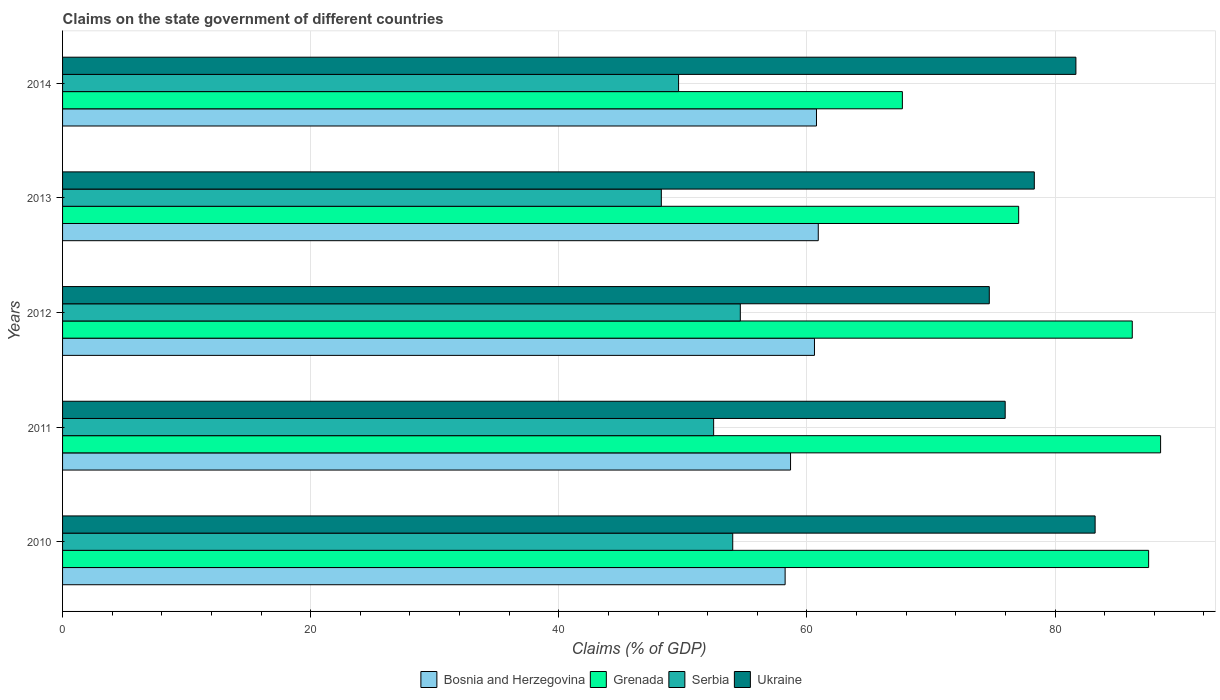How many groups of bars are there?
Keep it short and to the point. 5. Are the number of bars per tick equal to the number of legend labels?
Make the answer very short. Yes. How many bars are there on the 4th tick from the bottom?
Keep it short and to the point. 4. What is the label of the 1st group of bars from the top?
Ensure brevity in your answer.  2014. In how many cases, is the number of bars for a given year not equal to the number of legend labels?
Provide a short and direct response. 0. What is the percentage of GDP claimed on the state government in Grenada in 2013?
Offer a very short reply. 77.07. Across all years, what is the maximum percentage of GDP claimed on the state government in Serbia?
Keep it short and to the point. 54.63. Across all years, what is the minimum percentage of GDP claimed on the state government in Bosnia and Herzegovina?
Make the answer very short. 58.24. In which year was the percentage of GDP claimed on the state government in Bosnia and Herzegovina minimum?
Provide a short and direct response. 2010. What is the total percentage of GDP claimed on the state government in Ukraine in the graph?
Your answer should be compact. 393.92. What is the difference between the percentage of GDP claimed on the state government in Bosnia and Herzegovina in 2010 and that in 2012?
Give a very brief answer. -2.37. What is the difference between the percentage of GDP claimed on the state government in Ukraine in 2010 and the percentage of GDP claimed on the state government in Bosnia and Herzegovina in 2014?
Offer a terse response. 22.46. What is the average percentage of GDP claimed on the state government in Ukraine per year?
Your response must be concise. 78.78. In the year 2013, what is the difference between the percentage of GDP claimed on the state government in Bosnia and Herzegovina and percentage of GDP claimed on the state government in Grenada?
Keep it short and to the point. -16.15. What is the ratio of the percentage of GDP claimed on the state government in Ukraine in 2011 to that in 2014?
Provide a short and direct response. 0.93. Is the difference between the percentage of GDP claimed on the state government in Bosnia and Herzegovina in 2013 and 2014 greater than the difference between the percentage of GDP claimed on the state government in Grenada in 2013 and 2014?
Your answer should be very brief. No. What is the difference between the highest and the second highest percentage of GDP claimed on the state government in Serbia?
Your response must be concise. 0.61. What is the difference between the highest and the lowest percentage of GDP claimed on the state government in Bosnia and Herzegovina?
Offer a very short reply. 2.67. Is it the case that in every year, the sum of the percentage of GDP claimed on the state government in Grenada and percentage of GDP claimed on the state government in Serbia is greater than the sum of percentage of GDP claimed on the state government in Ukraine and percentage of GDP claimed on the state government in Bosnia and Herzegovina?
Ensure brevity in your answer.  No. What does the 4th bar from the top in 2013 represents?
Your response must be concise. Bosnia and Herzegovina. What does the 4th bar from the bottom in 2012 represents?
Ensure brevity in your answer.  Ukraine. How many bars are there?
Your response must be concise. 20. Are all the bars in the graph horizontal?
Give a very brief answer. Yes. How many years are there in the graph?
Your response must be concise. 5. What is the difference between two consecutive major ticks on the X-axis?
Offer a terse response. 20. Does the graph contain any zero values?
Your response must be concise. No. Where does the legend appear in the graph?
Your response must be concise. Bottom center. How are the legend labels stacked?
Provide a succinct answer. Horizontal. What is the title of the graph?
Offer a very short reply. Claims on the state government of different countries. What is the label or title of the X-axis?
Offer a very short reply. Claims (% of GDP). What is the label or title of the Y-axis?
Give a very brief answer. Years. What is the Claims (% of GDP) of Bosnia and Herzegovina in 2010?
Make the answer very short. 58.24. What is the Claims (% of GDP) in Grenada in 2010?
Offer a very short reply. 87.54. What is the Claims (% of GDP) in Serbia in 2010?
Your answer should be compact. 54.02. What is the Claims (% of GDP) of Ukraine in 2010?
Your answer should be compact. 83.23. What is the Claims (% of GDP) in Bosnia and Herzegovina in 2011?
Give a very brief answer. 58.68. What is the Claims (% of GDP) in Grenada in 2011?
Give a very brief answer. 88.51. What is the Claims (% of GDP) of Serbia in 2011?
Provide a succinct answer. 52.48. What is the Claims (% of GDP) of Ukraine in 2011?
Ensure brevity in your answer.  75.98. What is the Claims (% of GDP) of Bosnia and Herzegovina in 2012?
Your response must be concise. 60.61. What is the Claims (% of GDP) of Grenada in 2012?
Your answer should be very brief. 86.22. What is the Claims (% of GDP) in Serbia in 2012?
Your answer should be compact. 54.63. What is the Claims (% of GDP) in Ukraine in 2012?
Keep it short and to the point. 74.7. What is the Claims (% of GDP) of Bosnia and Herzegovina in 2013?
Your answer should be very brief. 60.91. What is the Claims (% of GDP) in Grenada in 2013?
Make the answer very short. 77.07. What is the Claims (% of GDP) in Serbia in 2013?
Offer a terse response. 48.26. What is the Claims (% of GDP) in Ukraine in 2013?
Offer a very short reply. 78.33. What is the Claims (% of GDP) in Bosnia and Herzegovina in 2014?
Keep it short and to the point. 60.77. What is the Claims (% of GDP) in Grenada in 2014?
Offer a very short reply. 67.69. What is the Claims (% of GDP) in Serbia in 2014?
Your response must be concise. 49.65. What is the Claims (% of GDP) in Ukraine in 2014?
Offer a terse response. 81.68. Across all years, what is the maximum Claims (% of GDP) in Bosnia and Herzegovina?
Offer a very short reply. 60.91. Across all years, what is the maximum Claims (% of GDP) of Grenada?
Ensure brevity in your answer.  88.51. Across all years, what is the maximum Claims (% of GDP) in Serbia?
Your response must be concise. 54.63. Across all years, what is the maximum Claims (% of GDP) in Ukraine?
Offer a terse response. 83.23. Across all years, what is the minimum Claims (% of GDP) of Bosnia and Herzegovina?
Make the answer very short. 58.24. Across all years, what is the minimum Claims (% of GDP) in Grenada?
Make the answer very short. 67.69. Across all years, what is the minimum Claims (% of GDP) in Serbia?
Your answer should be compact. 48.26. Across all years, what is the minimum Claims (% of GDP) in Ukraine?
Your response must be concise. 74.7. What is the total Claims (% of GDP) in Bosnia and Herzegovina in the graph?
Keep it short and to the point. 299.21. What is the total Claims (% of GDP) of Grenada in the graph?
Your response must be concise. 407.03. What is the total Claims (% of GDP) in Serbia in the graph?
Offer a terse response. 259.05. What is the total Claims (% of GDP) in Ukraine in the graph?
Give a very brief answer. 393.92. What is the difference between the Claims (% of GDP) in Bosnia and Herzegovina in 2010 and that in 2011?
Ensure brevity in your answer.  -0.44. What is the difference between the Claims (% of GDP) in Grenada in 2010 and that in 2011?
Provide a succinct answer. -0.97. What is the difference between the Claims (% of GDP) in Serbia in 2010 and that in 2011?
Your answer should be compact. 1.54. What is the difference between the Claims (% of GDP) in Ukraine in 2010 and that in 2011?
Your response must be concise. 7.25. What is the difference between the Claims (% of GDP) in Bosnia and Herzegovina in 2010 and that in 2012?
Offer a terse response. -2.37. What is the difference between the Claims (% of GDP) in Grenada in 2010 and that in 2012?
Offer a terse response. 1.32. What is the difference between the Claims (% of GDP) in Serbia in 2010 and that in 2012?
Make the answer very short. -0.61. What is the difference between the Claims (% of GDP) of Ukraine in 2010 and that in 2012?
Offer a very short reply. 8.53. What is the difference between the Claims (% of GDP) in Bosnia and Herzegovina in 2010 and that in 2013?
Provide a succinct answer. -2.67. What is the difference between the Claims (% of GDP) in Grenada in 2010 and that in 2013?
Make the answer very short. 10.47. What is the difference between the Claims (% of GDP) in Serbia in 2010 and that in 2013?
Provide a short and direct response. 5.76. What is the difference between the Claims (% of GDP) in Ukraine in 2010 and that in 2013?
Make the answer very short. 4.9. What is the difference between the Claims (% of GDP) in Bosnia and Herzegovina in 2010 and that in 2014?
Ensure brevity in your answer.  -2.53. What is the difference between the Claims (% of GDP) of Grenada in 2010 and that in 2014?
Your response must be concise. 19.85. What is the difference between the Claims (% of GDP) in Serbia in 2010 and that in 2014?
Your answer should be very brief. 4.37. What is the difference between the Claims (% of GDP) in Ukraine in 2010 and that in 2014?
Your answer should be very brief. 1.55. What is the difference between the Claims (% of GDP) in Bosnia and Herzegovina in 2011 and that in 2012?
Ensure brevity in your answer.  -1.93. What is the difference between the Claims (% of GDP) in Grenada in 2011 and that in 2012?
Offer a terse response. 2.28. What is the difference between the Claims (% of GDP) of Serbia in 2011 and that in 2012?
Keep it short and to the point. -2.15. What is the difference between the Claims (% of GDP) in Ukraine in 2011 and that in 2012?
Your answer should be very brief. 1.28. What is the difference between the Claims (% of GDP) in Bosnia and Herzegovina in 2011 and that in 2013?
Provide a short and direct response. -2.23. What is the difference between the Claims (% of GDP) of Grenada in 2011 and that in 2013?
Make the answer very short. 11.44. What is the difference between the Claims (% of GDP) in Serbia in 2011 and that in 2013?
Offer a terse response. 4.22. What is the difference between the Claims (% of GDP) of Ukraine in 2011 and that in 2013?
Keep it short and to the point. -2.35. What is the difference between the Claims (% of GDP) of Bosnia and Herzegovina in 2011 and that in 2014?
Your answer should be compact. -2.09. What is the difference between the Claims (% of GDP) of Grenada in 2011 and that in 2014?
Provide a short and direct response. 20.81. What is the difference between the Claims (% of GDP) in Serbia in 2011 and that in 2014?
Offer a very short reply. 2.83. What is the difference between the Claims (% of GDP) of Ukraine in 2011 and that in 2014?
Provide a short and direct response. -5.7. What is the difference between the Claims (% of GDP) of Bosnia and Herzegovina in 2012 and that in 2013?
Your answer should be very brief. -0.31. What is the difference between the Claims (% of GDP) in Grenada in 2012 and that in 2013?
Provide a succinct answer. 9.16. What is the difference between the Claims (% of GDP) in Serbia in 2012 and that in 2013?
Your answer should be very brief. 6.37. What is the difference between the Claims (% of GDP) in Ukraine in 2012 and that in 2013?
Keep it short and to the point. -3.63. What is the difference between the Claims (% of GDP) of Bosnia and Herzegovina in 2012 and that in 2014?
Your answer should be very brief. -0.16. What is the difference between the Claims (% of GDP) in Grenada in 2012 and that in 2014?
Provide a short and direct response. 18.53. What is the difference between the Claims (% of GDP) of Serbia in 2012 and that in 2014?
Your answer should be compact. 4.98. What is the difference between the Claims (% of GDP) of Ukraine in 2012 and that in 2014?
Provide a short and direct response. -6.98. What is the difference between the Claims (% of GDP) in Bosnia and Herzegovina in 2013 and that in 2014?
Offer a terse response. 0.14. What is the difference between the Claims (% of GDP) in Grenada in 2013 and that in 2014?
Provide a succinct answer. 9.37. What is the difference between the Claims (% of GDP) in Serbia in 2013 and that in 2014?
Your answer should be very brief. -1.39. What is the difference between the Claims (% of GDP) of Ukraine in 2013 and that in 2014?
Your answer should be very brief. -3.35. What is the difference between the Claims (% of GDP) in Bosnia and Herzegovina in 2010 and the Claims (% of GDP) in Grenada in 2011?
Offer a very short reply. -30.26. What is the difference between the Claims (% of GDP) of Bosnia and Herzegovina in 2010 and the Claims (% of GDP) of Serbia in 2011?
Give a very brief answer. 5.76. What is the difference between the Claims (% of GDP) of Bosnia and Herzegovina in 2010 and the Claims (% of GDP) of Ukraine in 2011?
Make the answer very short. -17.74. What is the difference between the Claims (% of GDP) of Grenada in 2010 and the Claims (% of GDP) of Serbia in 2011?
Provide a succinct answer. 35.06. What is the difference between the Claims (% of GDP) in Grenada in 2010 and the Claims (% of GDP) in Ukraine in 2011?
Your answer should be compact. 11.56. What is the difference between the Claims (% of GDP) of Serbia in 2010 and the Claims (% of GDP) of Ukraine in 2011?
Offer a very short reply. -21.96. What is the difference between the Claims (% of GDP) of Bosnia and Herzegovina in 2010 and the Claims (% of GDP) of Grenada in 2012?
Make the answer very short. -27.98. What is the difference between the Claims (% of GDP) of Bosnia and Herzegovina in 2010 and the Claims (% of GDP) of Serbia in 2012?
Provide a short and direct response. 3.61. What is the difference between the Claims (% of GDP) in Bosnia and Herzegovina in 2010 and the Claims (% of GDP) in Ukraine in 2012?
Offer a very short reply. -16.46. What is the difference between the Claims (% of GDP) of Grenada in 2010 and the Claims (% of GDP) of Serbia in 2012?
Provide a short and direct response. 32.91. What is the difference between the Claims (% of GDP) in Grenada in 2010 and the Claims (% of GDP) in Ukraine in 2012?
Keep it short and to the point. 12.84. What is the difference between the Claims (% of GDP) of Serbia in 2010 and the Claims (% of GDP) of Ukraine in 2012?
Make the answer very short. -20.68. What is the difference between the Claims (% of GDP) in Bosnia and Herzegovina in 2010 and the Claims (% of GDP) in Grenada in 2013?
Your response must be concise. -18.82. What is the difference between the Claims (% of GDP) of Bosnia and Herzegovina in 2010 and the Claims (% of GDP) of Serbia in 2013?
Your response must be concise. 9.98. What is the difference between the Claims (% of GDP) of Bosnia and Herzegovina in 2010 and the Claims (% of GDP) of Ukraine in 2013?
Offer a very short reply. -20.09. What is the difference between the Claims (% of GDP) in Grenada in 2010 and the Claims (% of GDP) in Serbia in 2013?
Ensure brevity in your answer.  39.28. What is the difference between the Claims (% of GDP) of Grenada in 2010 and the Claims (% of GDP) of Ukraine in 2013?
Your answer should be very brief. 9.21. What is the difference between the Claims (% of GDP) in Serbia in 2010 and the Claims (% of GDP) in Ukraine in 2013?
Your response must be concise. -24.31. What is the difference between the Claims (% of GDP) in Bosnia and Herzegovina in 2010 and the Claims (% of GDP) in Grenada in 2014?
Offer a terse response. -9.45. What is the difference between the Claims (% of GDP) in Bosnia and Herzegovina in 2010 and the Claims (% of GDP) in Serbia in 2014?
Offer a very short reply. 8.59. What is the difference between the Claims (% of GDP) in Bosnia and Herzegovina in 2010 and the Claims (% of GDP) in Ukraine in 2014?
Give a very brief answer. -23.44. What is the difference between the Claims (% of GDP) of Grenada in 2010 and the Claims (% of GDP) of Serbia in 2014?
Provide a short and direct response. 37.89. What is the difference between the Claims (% of GDP) in Grenada in 2010 and the Claims (% of GDP) in Ukraine in 2014?
Provide a succinct answer. 5.86. What is the difference between the Claims (% of GDP) of Serbia in 2010 and the Claims (% of GDP) of Ukraine in 2014?
Give a very brief answer. -27.66. What is the difference between the Claims (% of GDP) of Bosnia and Herzegovina in 2011 and the Claims (% of GDP) of Grenada in 2012?
Keep it short and to the point. -27.54. What is the difference between the Claims (% of GDP) of Bosnia and Herzegovina in 2011 and the Claims (% of GDP) of Serbia in 2012?
Make the answer very short. 4.05. What is the difference between the Claims (% of GDP) of Bosnia and Herzegovina in 2011 and the Claims (% of GDP) of Ukraine in 2012?
Give a very brief answer. -16.02. What is the difference between the Claims (% of GDP) of Grenada in 2011 and the Claims (% of GDP) of Serbia in 2012?
Make the answer very short. 33.88. What is the difference between the Claims (% of GDP) of Grenada in 2011 and the Claims (% of GDP) of Ukraine in 2012?
Your answer should be very brief. 13.81. What is the difference between the Claims (% of GDP) of Serbia in 2011 and the Claims (% of GDP) of Ukraine in 2012?
Your answer should be very brief. -22.22. What is the difference between the Claims (% of GDP) of Bosnia and Herzegovina in 2011 and the Claims (% of GDP) of Grenada in 2013?
Offer a very short reply. -18.39. What is the difference between the Claims (% of GDP) in Bosnia and Herzegovina in 2011 and the Claims (% of GDP) in Serbia in 2013?
Offer a terse response. 10.41. What is the difference between the Claims (% of GDP) in Bosnia and Herzegovina in 2011 and the Claims (% of GDP) in Ukraine in 2013?
Your answer should be very brief. -19.65. What is the difference between the Claims (% of GDP) in Grenada in 2011 and the Claims (% of GDP) in Serbia in 2013?
Your answer should be very brief. 40.24. What is the difference between the Claims (% of GDP) in Grenada in 2011 and the Claims (% of GDP) in Ukraine in 2013?
Give a very brief answer. 10.18. What is the difference between the Claims (% of GDP) of Serbia in 2011 and the Claims (% of GDP) of Ukraine in 2013?
Offer a terse response. -25.85. What is the difference between the Claims (% of GDP) in Bosnia and Herzegovina in 2011 and the Claims (% of GDP) in Grenada in 2014?
Provide a succinct answer. -9.01. What is the difference between the Claims (% of GDP) in Bosnia and Herzegovina in 2011 and the Claims (% of GDP) in Serbia in 2014?
Provide a short and direct response. 9.03. What is the difference between the Claims (% of GDP) of Bosnia and Herzegovina in 2011 and the Claims (% of GDP) of Ukraine in 2014?
Offer a very short reply. -23. What is the difference between the Claims (% of GDP) in Grenada in 2011 and the Claims (% of GDP) in Serbia in 2014?
Offer a very short reply. 38.85. What is the difference between the Claims (% of GDP) in Grenada in 2011 and the Claims (% of GDP) in Ukraine in 2014?
Offer a very short reply. 6.83. What is the difference between the Claims (% of GDP) in Serbia in 2011 and the Claims (% of GDP) in Ukraine in 2014?
Your answer should be very brief. -29.2. What is the difference between the Claims (% of GDP) of Bosnia and Herzegovina in 2012 and the Claims (% of GDP) of Grenada in 2013?
Give a very brief answer. -16.46. What is the difference between the Claims (% of GDP) in Bosnia and Herzegovina in 2012 and the Claims (% of GDP) in Serbia in 2013?
Make the answer very short. 12.34. What is the difference between the Claims (% of GDP) in Bosnia and Herzegovina in 2012 and the Claims (% of GDP) in Ukraine in 2013?
Your response must be concise. -17.72. What is the difference between the Claims (% of GDP) in Grenada in 2012 and the Claims (% of GDP) in Serbia in 2013?
Offer a terse response. 37.96. What is the difference between the Claims (% of GDP) of Grenada in 2012 and the Claims (% of GDP) of Ukraine in 2013?
Your answer should be very brief. 7.9. What is the difference between the Claims (% of GDP) in Serbia in 2012 and the Claims (% of GDP) in Ukraine in 2013?
Your response must be concise. -23.7. What is the difference between the Claims (% of GDP) of Bosnia and Herzegovina in 2012 and the Claims (% of GDP) of Grenada in 2014?
Keep it short and to the point. -7.09. What is the difference between the Claims (% of GDP) of Bosnia and Herzegovina in 2012 and the Claims (% of GDP) of Serbia in 2014?
Ensure brevity in your answer.  10.95. What is the difference between the Claims (% of GDP) in Bosnia and Herzegovina in 2012 and the Claims (% of GDP) in Ukraine in 2014?
Your answer should be very brief. -21.07. What is the difference between the Claims (% of GDP) in Grenada in 2012 and the Claims (% of GDP) in Serbia in 2014?
Your answer should be very brief. 36.57. What is the difference between the Claims (% of GDP) in Grenada in 2012 and the Claims (% of GDP) in Ukraine in 2014?
Make the answer very short. 4.54. What is the difference between the Claims (% of GDP) of Serbia in 2012 and the Claims (% of GDP) of Ukraine in 2014?
Keep it short and to the point. -27.05. What is the difference between the Claims (% of GDP) in Bosnia and Herzegovina in 2013 and the Claims (% of GDP) in Grenada in 2014?
Your answer should be compact. -6.78. What is the difference between the Claims (% of GDP) of Bosnia and Herzegovina in 2013 and the Claims (% of GDP) of Serbia in 2014?
Your answer should be very brief. 11.26. What is the difference between the Claims (% of GDP) in Bosnia and Herzegovina in 2013 and the Claims (% of GDP) in Ukraine in 2014?
Offer a terse response. -20.77. What is the difference between the Claims (% of GDP) of Grenada in 2013 and the Claims (% of GDP) of Serbia in 2014?
Give a very brief answer. 27.41. What is the difference between the Claims (% of GDP) of Grenada in 2013 and the Claims (% of GDP) of Ukraine in 2014?
Keep it short and to the point. -4.61. What is the difference between the Claims (% of GDP) of Serbia in 2013 and the Claims (% of GDP) of Ukraine in 2014?
Make the answer very short. -33.42. What is the average Claims (% of GDP) in Bosnia and Herzegovina per year?
Offer a terse response. 59.84. What is the average Claims (% of GDP) in Grenada per year?
Keep it short and to the point. 81.41. What is the average Claims (% of GDP) of Serbia per year?
Keep it short and to the point. 51.81. What is the average Claims (% of GDP) in Ukraine per year?
Offer a very short reply. 78.78. In the year 2010, what is the difference between the Claims (% of GDP) in Bosnia and Herzegovina and Claims (% of GDP) in Grenada?
Your answer should be very brief. -29.3. In the year 2010, what is the difference between the Claims (% of GDP) of Bosnia and Herzegovina and Claims (% of GDP) of Serbia?
Your answer should be very brief. 4.22. In the year 2010, what is the difference between the Claims (% of GDP) of Bosnia and Herzegovina and Claims (% of GDP) of Ukraine?
Keep it short and to the point. -24.99. In the year 2010, what is the difference between the Claims (% of GDP) of Grenada and Claims (% of GDP) of Serbia?
Give a very brief answer. 33.52. In the year 2010, what is the difference between the Claims (% of GDP) of Grenada and Claims (% of GDP) of Ukraine?
Provide a succinct answer. 4.31. In the year 2010, what is the difference between the Claims (% of GDP) in Serbia and Claims (% of GDP) in Ukraine?
Your answer should be compact. -29.21. In the year 2011, what is the difference between the Claims (% of GDP) in Bosnia and Herzegovina and Claims (% of GDP) in Grenada?
Make the answer very short. -29.83. In the year 2011, what is the difference between the Claims (% of GDP) of Bosnia and Herzegovina and Claims (% of GDP) of Serbia?
Provide a succinct answer. 6.2. In the year 2011, what is the difference between the Claims (% of GDP) of Bosnia and Herzegovina and Claims (% of GDP) of Ukraine?
Your answer should be compact. -17.3. In the year 2011, what is the difference between the Claims (% of GDP) in Grenada and Claims (% of GDP) in Serbia?
Your response must be concise. 36.03. In the year 2011, what is the difference between the Claims (% of GDP) of Grenada and Claims (% of GDP) of Ukraine?
Ensure brevity in your answer.  12.53. In the year 2011, what is the difference between the Claims (% of GDP) of Serbia and Claims (% of GDP) of Ukraine?
Provide a short and direct response. -23.5. In the year 2012, what is the difference between the Claims (% of GDP) of Bosnia and Herzegovina and Claims (% of GDP) of Grenada?
Keep it short and to the point. -25.62. In the year 2012, what is the difference between the Claims (% of GDP) in Bosnia and Herzegovina and Claims (% of GDP) in Serbia?
Keep it short and to the point. 5.98. In the year 2012, what is the difference between the Claims (% of GDP) in Bosnia and Herzegovina and Claims (% of GDP) in Ukraine?
Your response must be concise. -14.09. In the year 2012, what is the difference between the Claims (% of GDP) of Grenada and Claims (% of GDP) of Serbia?
Offer a very short reply. 31.59. In the year 2012, what is the difference between the Claims (% of GDP) of Grenada and Claims (% of GDP) of Ukraine?
Offer a very short reply. 11.52. In the year 2012, what is the difference between the Claims (% of GDP) in Serbia and Claims (% of GDP) in Ukraine?
Provide a succinct answer. -20.07. In the year 2013, what is the difference between the Claims (% of GDP) in Bosnia and Herzegovina and Claims (% of GDP) in Grenada?
Offer a terse response. -16.15. In the year 2013, what is the difference between the Claims (% of GDP) of Bosnia and Herzegovina and Claims (% of GDP) of Serbia?
Keep it short and to the point. 12.65. In the year 2013, what is the difference between the Claims (% of GDP) of Bosnia and Herzegovina and Claims (% of GDP) of Ukraine?
Your answer should be very brief. -17.41. In the year 2013, what is the difference between the Claims (% of GDP) in Grenada and Claims (% of GDP) in Serbia?
Ensure brevity in your answer.  28.8. In the year 2013, what is the difference between the Claims (% of GDP) of Grenada and Claims (% of GDP) of Ukraine?
Make the answer very short. -1.26. In the year 2013, what is the difference between the Claims (% of GDP) in Serbia and Claims (% of GDP) in Ukraine?
Offer a terse response. -30.06. In the year 2014, what is the difference between the Claims (% of GDP) in Bosnia and Herzegovina and Claims (% of GDP) in Grenada?
Ensure brevity in your answer.  -6.92. In the year 2014, what is the difference between the Claims (% of GDP) of Bosnia and Herzegovina and Claims (% of GDP) of Serbia?
Ensure brevity in your answer.  11.12. In the year 2014, what is the difference between the Claims (% of GDP) in Bosnia and Herzegovina and Claims (% of GDP) in Ukraine?
Provide a short and direct response. -20.91. In the year 2014, what is the difference between the Claims (% of GDP) in Grenada and Claims (% of GDP) in Serbia?
Your answer should be compact. 18.04. In the year 2014, what is the difference between the Claims (% of GDP) in Grenada and Claims (% of GDP) in Ukraine?
Your answer should be compact. -13.99. In the year 2014, what is the difference between the Claims (% of GDP) of Serbia and Claims (% of GDP) of Ukraine?
Make the answer very short. -32.03. What is the ratio of the Claims (% of GDP) of Grenada in 2010 to that in 2011?
Offer a very short reply. 0.99. What is the ratio of the Claims (% of GDP) in Serbia in 2010 to that in 2011?
Make the answer very short. 1.03. What is the ratio of the Claims (% of GDP) of Ukraine in 2010 to that in 2011?
Offer a very short reply. 1.1. What is the ratio of the Claims (% of GDP) of Bosnia and Herzegovina in 2010 to that in 2012?
Your answer should be very brief. 0.96. What is the ratio of the Claims (% of GDP) in Grenada in 2010 to that in 2012?
Provide a short and direct response. 1.02. What is the ratio of the Claims (% of GDP) of Ukraine in 2010 to that in 2012?
Give a very brief answer. 1.11. What is the ratio of the Claims (% of GDP) in Bosnia and Herzegovina in 2010 to that in 2013?
Offer a very short reply. 0.96. What is the ratio of the Claims (% of GDP) of Grenada in 2010 to that in 2013?
Keep it short and to the point. 1.14. What is the ratio of the Claims (% of GDP) of Serbia in 2010 to that in 2013?
Your answer should be compact. 1.12. What is the ratio of the Claims (% of GDP) in Ukraine in 2010 to that in 2013?
Make the answer very short. 1.06. What is the ratio of the Claims (% of GDP) of Bosnia and Herzegovina in 2010 to that in 2014?
Make the answer very short. 0.96. What is the ratio of the Claims (% of GDP) in Grenada in 2010 to that in 2014?
Ensure brevity in your answer.  1.29. What is the ratio of the Claims (% of GDP) of Serbia in 2010 to that in 2014?
Your answer should be compact. 1.09. What is the ratio of the Claims (% of GDP) in Ukraine in 2010 to that in 2014?
Keep it short and to the point. 1.02. What is the ratio of the Claims (% of GDP) of Bosnia and Herzegovina in 2011 to that in 2012?
Your response must be concise. 0.97. What is the ratio of the Claims (% of GDP) in Grenada in 2011 to that in 2012?
Your answer should be compact. 1.03. What is the ratio of the Claims (% of GDP) of Serbia in 2011 to that in 2012?
Keep it short and to the point. 0.96. What is the ratio of the Claims (% of GDP) of Ukraine in 2011 to that in 2012?
Your answer should be very brief. 1.02. What is the ratio of the Claims (% of GDP) in Bosnia and Herzegovina in 2011 to that in 2013?
Make the answer very short. 0.96. What is the ratio of the Claims (% of GDP) in Grenada in 2011 to that in 2013?
Your answer should be compact. 1.15. What is the ratio of the Claims (% of GDP) in Serbia in 2011 to that in 2013?
Provide a succinct answer. 1.09. What is the ratio of the Claims (% of GDP) in Ukraine in 2011 to that in 2013?
Ensure brevity in your answer.  0.97. What is the ratio of the Claims (% of GDP) in Bosnia and Herzegovina in 2011 to that in 2014?
Ensure brevity in your answer.  0.97. What is the ratio of the Claims (% of GDP) in Grenada in 2011 to that in 2014?
Keep it short and to the point. 1.31. What is the ratio of the Claims (% of GDP) in Serbia in 2011 to that in 2014?
Keep it short and to the point. 1.06. What is the ratio of the Claims (% of GDP) of Ukraine in 2011 to that in 2014?
Keep it short and to the point. 0.93. What is the ratio of the Claims (% of GDP) in Bosnia and Herzegovina in 2012 to that in 2013?
Give a very brief answer. 0.99. What is the ratio of the Claims (% of GDP) of Grenada in 2012 to that in 2013?
Make the answer very short. 1.12. What is the ratio of the Claims (% of GDP) of Serbia in 2012 to that in 2013?
Keep it short and to the point. 1.13. What is the ratio of the Claims (% of GDP) of Ukraine in 2012 to that in 2013?
Ensure brevity in your answer.  0.95. What is the ratio of the Claims (% of GDP) in Bosnia and Herzegovina in 2012 to that in 2014?
Your answer should be compact. 1. What is the ratio of the Claims (% of GDP) in Grenada in 2012 to that in 2014?
Give a very brief answer. 1.27. What is the ratio of the Claims (% of GDP) in Serbia in 2012 to that in 2014?
Provide a short and direct response. 1.1. What is the ratio of the Claims (% of GDP) in Ukraine in 2012 to that in 2014?
Your response must be concise. 0.91. What is the ratio of the Claims (% of GDP) of Grenada in 2013 to that in 2014?
Keep it short and to the point. 1.14. What is the ratio of the Claims (% of GDP) in Ukraine in 2013 to that in 2014?
Your answer should be compact. 0.96. What is the difference between the highest and the second highest Claims (% of GDP) in Bosnia and Herzegovina?
Ensure brevity in your answer.  0.14. What is the difference between the highest and the second highest Claims (% of GDP) in Grenada?
Ensure brevity in your answer.  0.97. What is the difference between the highest and the second highest Claims (% of GDP) of Serbia?
Provide a short and direct response. 0.61. What is the difference between the highest and the second highest Claims (% of GDP) of Ukraine?
Your response must be concise. 1.55. What is the difference between the highest and the lowest Claims (% of GDP) in Bosnia and Herzegovina?
Your response must be concise. 2.67. What is the difference between the highest and the lowest Claims (% of GDP) of Grenada?
Offer a terse response. 20.81. What is the difference between the highest and the lowest Claims (% of GDP) in Serbia?
Provide a short and direct response. 6.37. What is the difference between the highest and the lowest Claims (% of GDP) of Ukraine?
Ensure brevity in your answer.  8.53. 